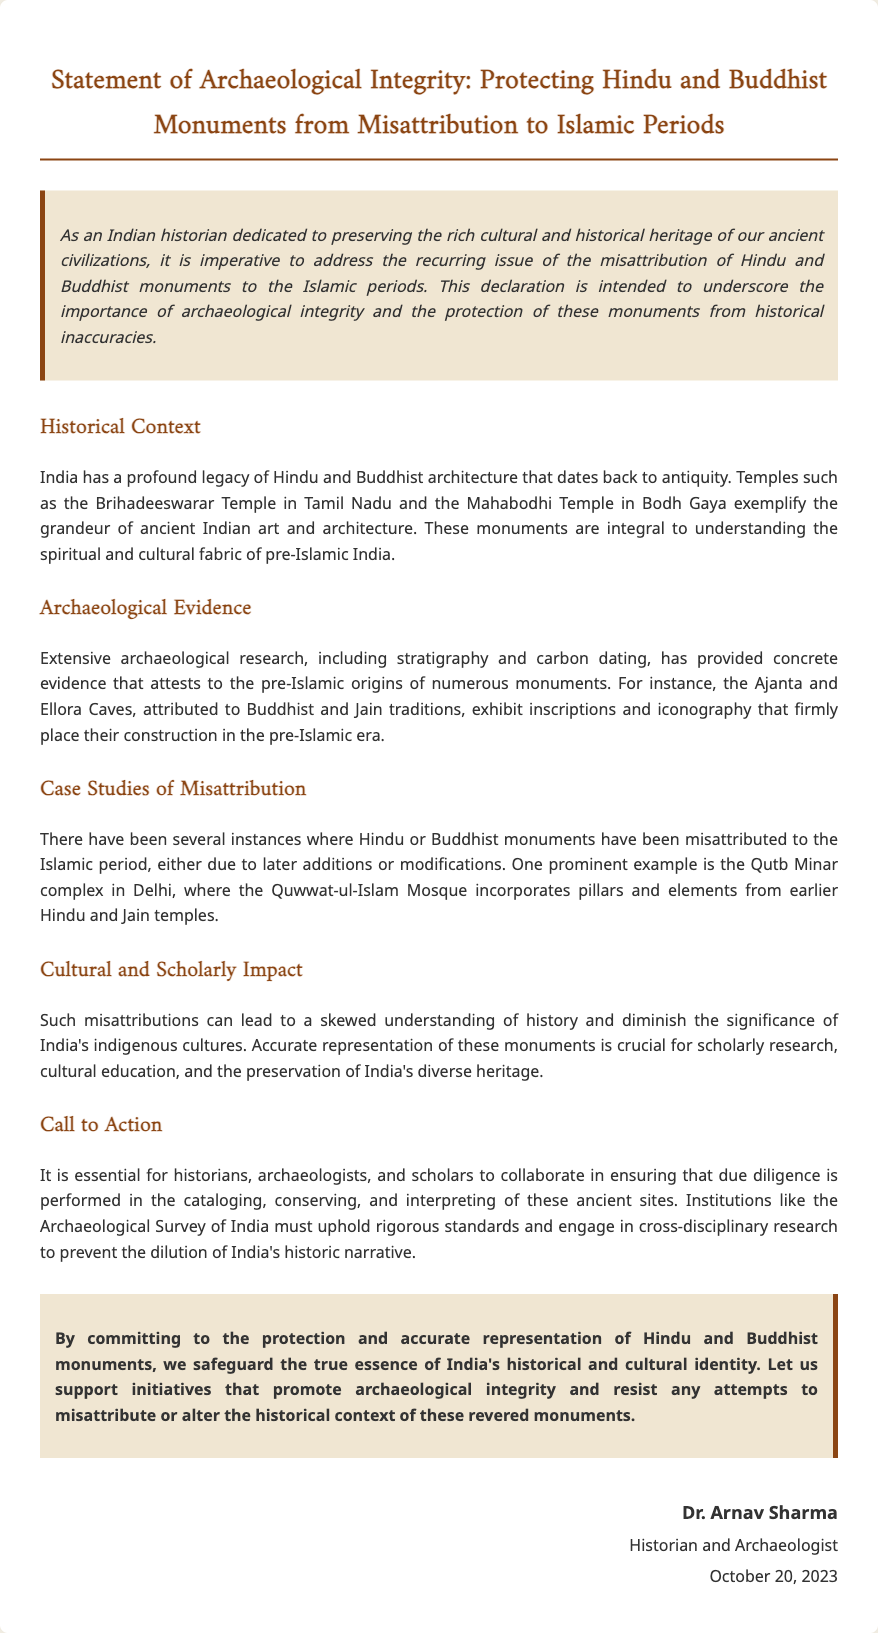What is the title of the document? The title of the document is provided at the beginning and it states the purpose of the declaration about archaeological integrity.
Answer: Statement of Archaeological Integrity: Protecting Hindu and Buddhist Monuments from Misattribution to Islamic Periods Who signed the document? The signature section reveals the name of the individual who supports this declaration, indicating their endorsement.
Answer: Dr. Arnav Sharma What is the date of the signature? The document includes the date in the signature section, indicating when the declaration was made.
Answer: October 20, 2023 What architectural feature is commonly misattributed to the Islamic period? The document discusses monuments that have faced misattribution, highlighting specific examples to illustrate this issue.
Answer: Hindu and Buddhist monuments Which temple is mentioned as an example of ancient Indian architecture? The document provides specific examples of important temples that showcase ancient Indian art and architecture, pointing to their historical significance.
Answer: Brihadeeswarar Temple What type of evidence is cited to support pre-Islamic origins of monuments? The document references methods used in archaeology to validate the historical timeline of these structures.
Answer: Stratigraphy and carbon dating What is a consequence of the misattribution of monuments? The text indicates a broader impact that misattribution has on understanding and representing historical narratives in India.
Answer: Skewed understanding of history Which institution is called to uphold rigorous standards? The document names an institution responsible for overseeing the preservation of historical sites, emphasizing its role in the community.
Answer: Archaeological Survey of India What does the conclusion urge historians and archaeologists to do? The concluding section summarizes the desired actions from professionals in the field to ensure that the archaeological narrative is preserved accurately.
Answer: Protect and accurately represent Hindu and Buddhist monuments 